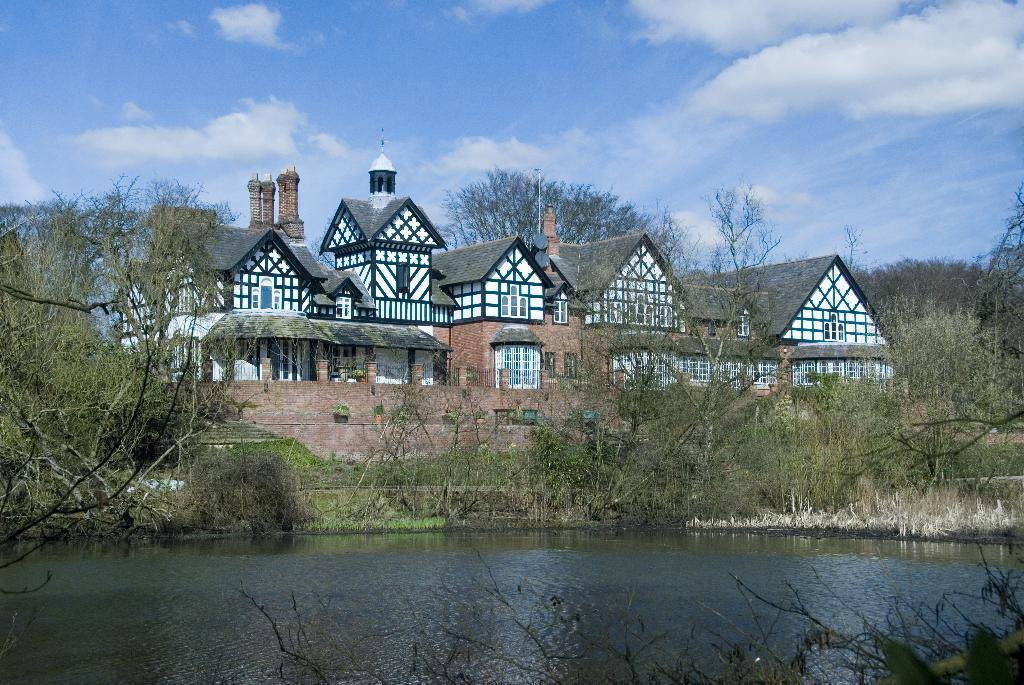What type of structure is present in the image? There is a building in the image. What natural elements can be seen in the image? There are plants, trees, and grass visible in the image. What is visible in the background of the image? The sky is visible in the background of the image. Can you see any writing on the trees in the image? There is no writing visible on the trees in the image. Is there a rabbit hopping through the grass in the image? There is no rabbit present in the image. 